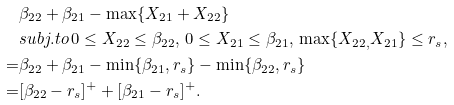Convert formula to latex. <formula><loc_0><loc_0><loc_500><loc_500>& \beta _ { 2 2 } + \beta _ { 2 1 } - \max \{ X _ { 2 1 } + X _ { 2 2 } \} \\ & s u b j . t o \, 0 \leq X _ { 2 2 } \leq \beta _ { 2 2 } , \, 0 \leq X _ { 2 1 } \leq \beta _ { 2 1 } , \, \max \{ X _ { 2 2 , } X _ { 2 1 } \} \leq r _ { s } , \\ = & \beta _ { 2 2 } + \beta _ { 2 1 } - \min \{ \beta _ { 2 1 } , r _ { s } \} - \min \{ \beta _ { 2 2 } , r _ { s } \} \\ = & [ \beta _ { 2 2 } - r _ { s } ] ^ { + } + [ \beta _ { 2 1 } - r _ { s } ] ^ { + } .</formula> 